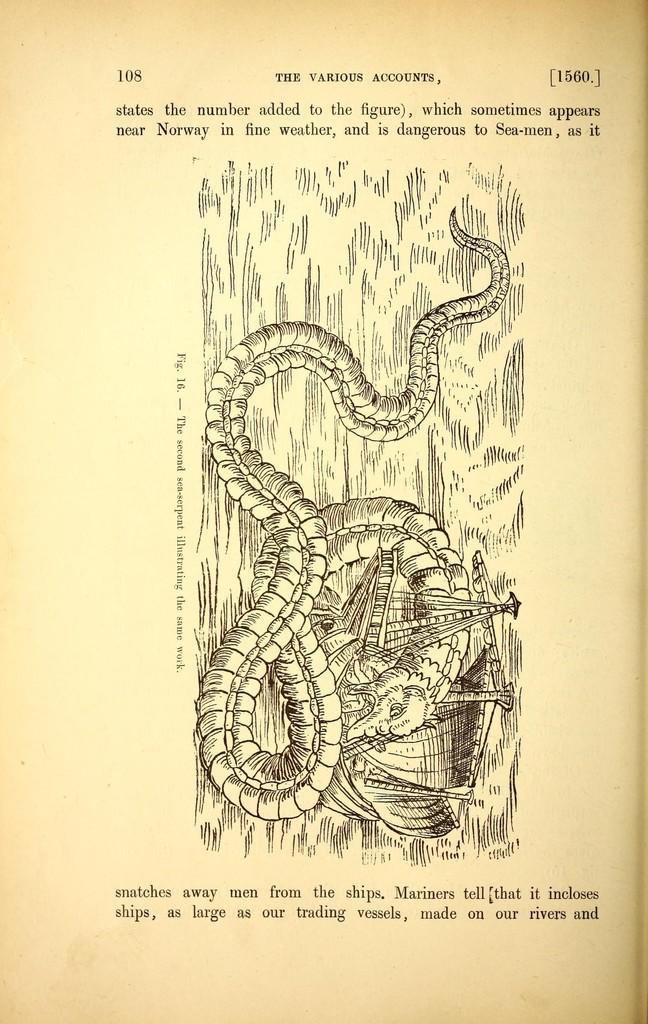In one or two sentences, can you explain what this image depicts? In the picture I can see a sketch of an animal and some other things. I can also see something written on the image. 